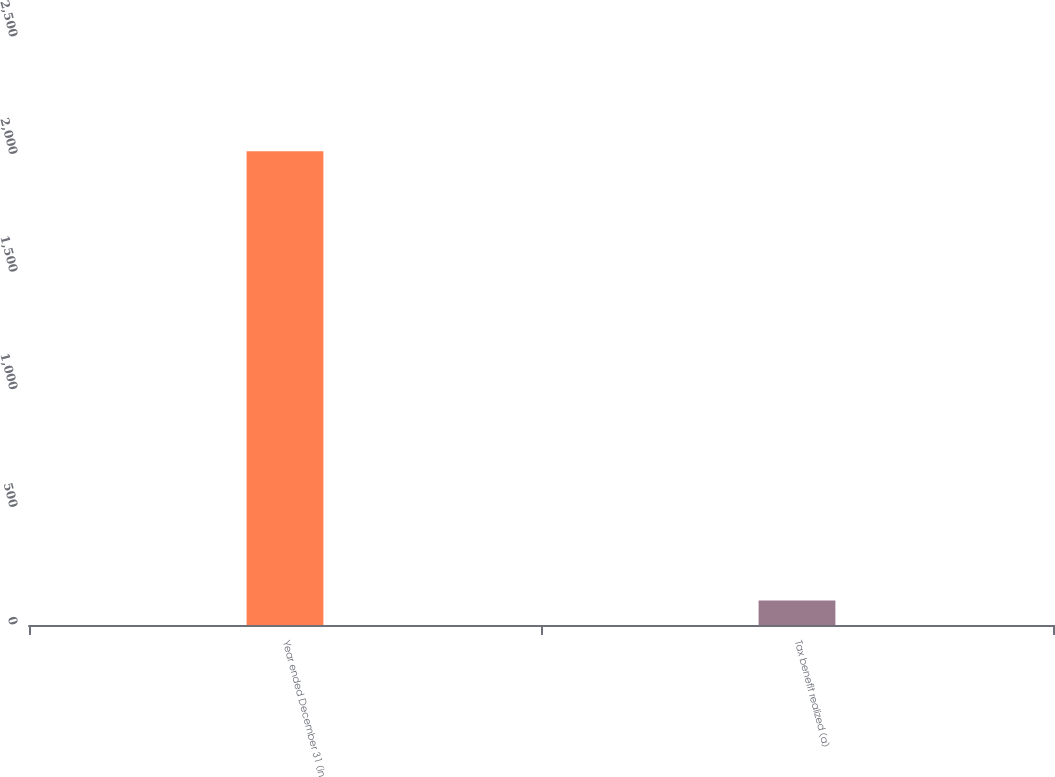<chart> <loc_0><loc_0><loc_500><loc_500><bar_chart><fcel>Year ended December 31 (in<fcel>Tax benefit realized (a)<nl><fcel>2014<fcel>104<nl></chart> 